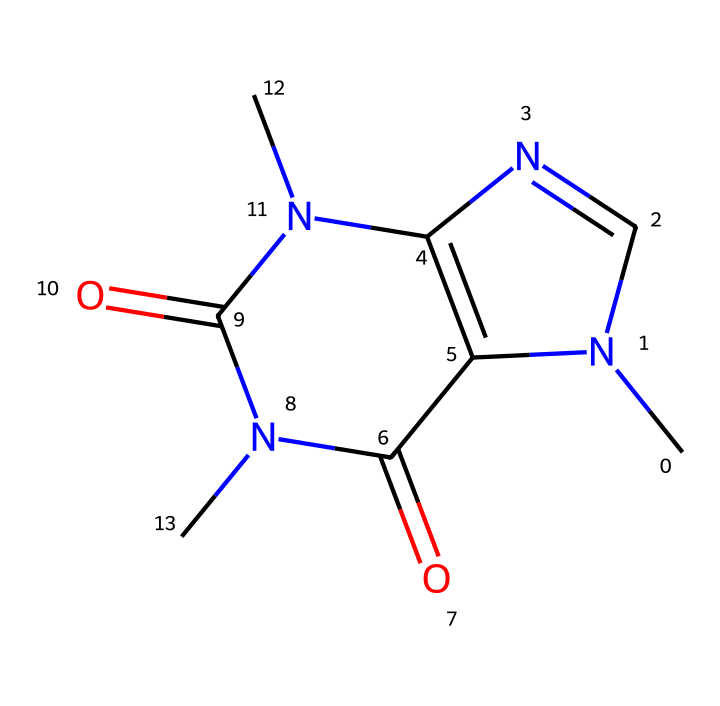What is the molecular formula of caffeine? The molecular formula can be derived from counting the different atoms present in the SMILES representation. It includes 8 carbon (C), 10 hydrogen (H), 4 nitrogen (N), and 2 oxygen (O) atoms, which results in the formula C8H10N4O2.
Answer: C8H10N4O2 How many nitrogen atoms are in the caffeine structure? By examining the SMILES notation, I can identify the nitrogen atoms present. There are four instances of the "N" symbol indicating that there are 4 nitrogen atoms in the structure.
Answer: 4 What type of chemical is caffeine classified as? Caffeine is classified as a base, specifically an alkaloid, due to the presence of nitrogen atoms which give it basic properties.
Answer: alkaloid How many rings are present in the caffeine structure? The structure includes two fused rings, as evident from the cyclic nature of the components in the SMILES notation. The numbering in the SMILES notation indicates the connection between the two rings.
Answer: 2 What is the total number of oxygen atoms in caffeine? The expression of "O" in the SMILES indicates the presence of two oxygen atoms in the structure, which can be directly counted from the representation.
Answer: 2 Which functional group can be identified in the caffeine structure? The presence of carbonyl groups (C=O) can be observed within the structure, indicating that caffeine has amide functional groups due to the arrangement of nitrogen and carbonyl components.
Answer: amide 